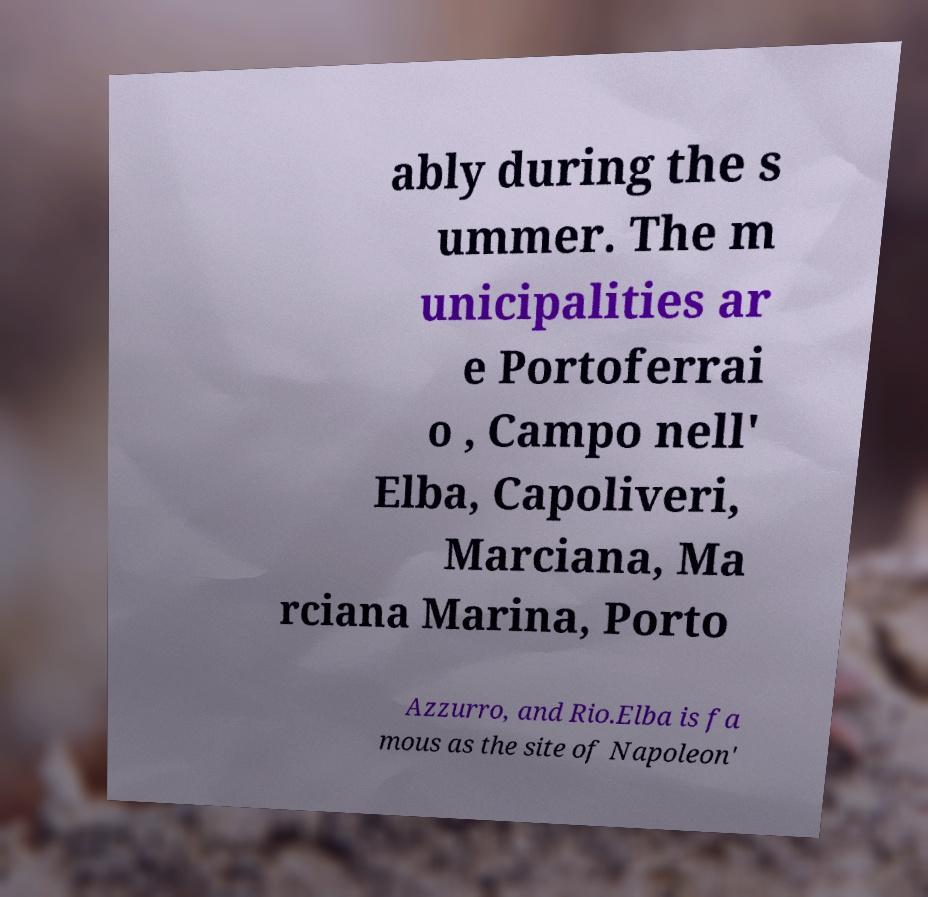Please read and relay the text visible in this image. What does it say? ably during the s ummer. The m unicipalities ar e Portoferrai o , Campo nell' Elba, Capoliveri, Marciana, Ma rciana Marina, Porto Azzurro, and Rio.Elba is fa mous as the site of Napoleon' 